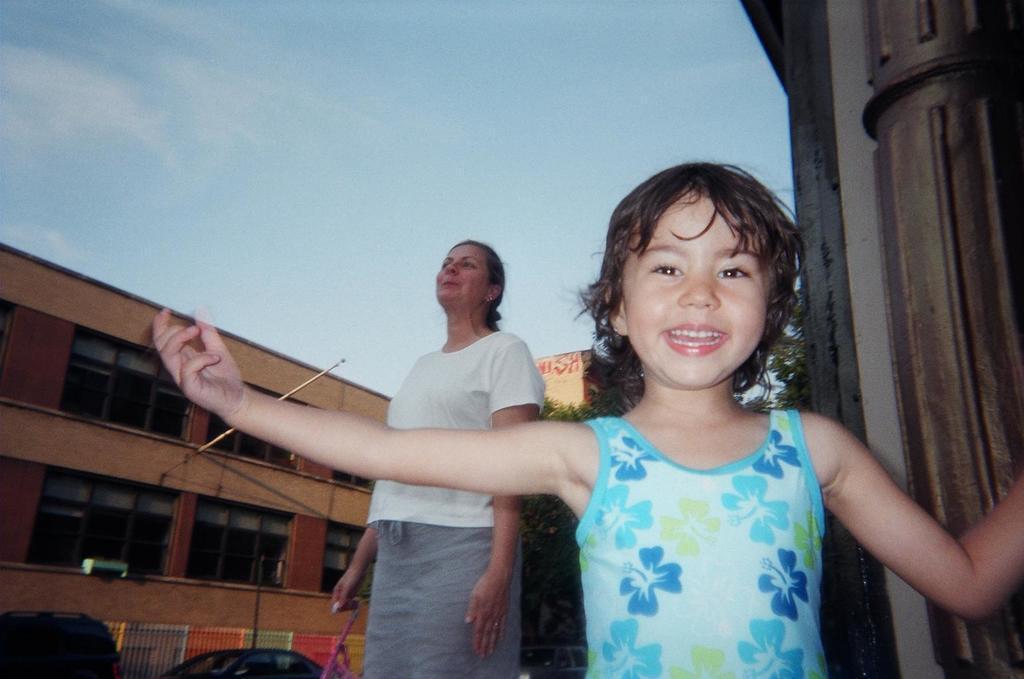Can you describe this image briefly? In the image we can see there is a girl standing and there is a woman standing and holding stick in her hand. Behind there are cars parked on the road and there is a building. 